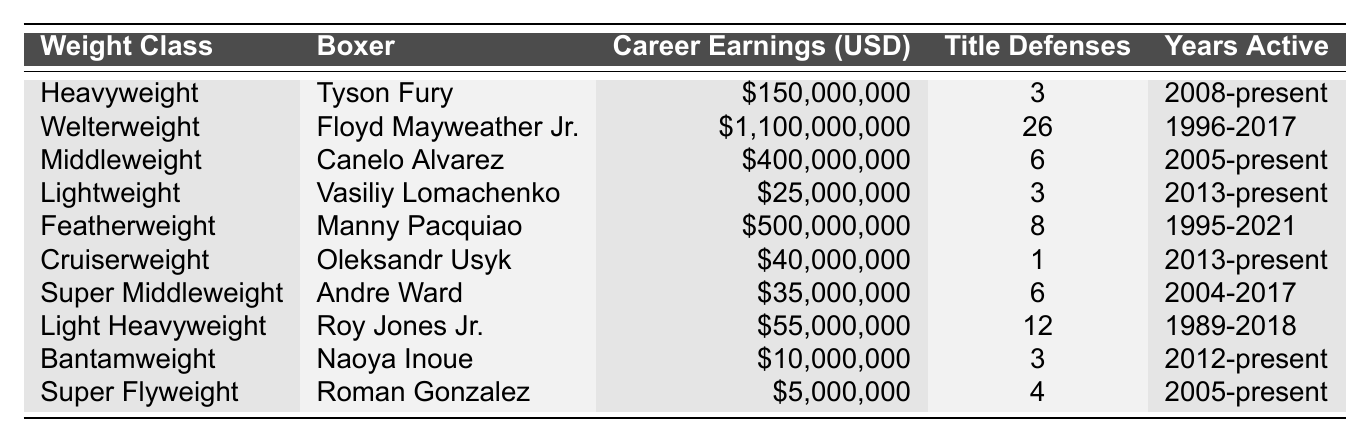What is the career earnings of Floyd Mayweather Jr.? The table lists Floyd Mayweather Jr. under the "Welterweight" weight class with career earnings of \$1,100,000,000.
Answer: \$1,100,000,000 Which boxer has the highest career earnings? By comparing the "Career Earnings (USD)" column, it is clear that Floyd Mayweather Jr. has the highest earnings at \$1,100,000,000.
Answer: Floyd Mayweather Jr How many title defenses does Canelo Alvarez have? The table indicates that Canelo Alvarez, under the "Middleweight" class, has 6 title defenses.
Answer: 6 What is the total number of title defenses for all boxers listed? The title defenses are 3 (Fury) + 26 (Mayweather Jr.) + 6 (Alvarez) + 3 (Lomachenko) + 8 (Pacquiao) + 1 (Usyk) + 6 (Ward) + 12 (Jones Jr.) + 3 (Inoue) + 4 (Gonzalez) = 72.
Answer: 72 What is the average career earnings of the boxers in the cruiserweight and featherweight classes? The career earnings for Oleksandr Usyk (Cruiserweight) is \$40,000,000 and for Manny Pacquiao (Featherweight) is \$500,000,000. Their total earnings are \$40,000,000 + \$500,000,000 = \$540,000,000, and there are 2 boxers, so the average is \$540,000,000 / 2 = \$270,000,000.
Answer: \$270,000,000 Does Naoya Inoue have more career earnings than Roman Gonzalez? The table shows Naoya Inoue with career earnings of \$10,000,000 and Roman Gonzalez with \$5,000,000. Since \$10,000,000 is greater than \$5,000,000, this statement is true.
Answer: Yes Which boxer has the fewest title defenses? Looking at the title defenses, Oleksandr Usyk has only 1 defense, which is the least amount compared to all listed boxers.
Answer: Oleksandr Usyk Is the average career earnings across all boxers more than \$100,000,000? Adding the career earnings gives \$1,100,000,000 + \$150,000,000 + \$400,000,000 + \$25,000,000 + \$500,000,000 + \$40,000,000 + \$35,000,000 + \$55,000,000 + \$10,000,000 + \$5,000,000 = \$2,415,000,000. Divided by 10 boxers results in an average of \$241,500,000, which is more than \$100,000,000.
Answer: Yes Which weight class has the most title defenses in total? Summing the title defenses: Heavyweight 3 + Welterweight 26 + Middleweight 6 + Lightweight 3 + Featherweight 8 + Cruiserweight 1 + Super Middleweight 6 + Light Heavyweight 12 + Bantamweight 3 + Super Flyweight 4 = 72. The Welterweight class contributes the most with 26 defenses.
Answer: Welterweight How many years has Roy Jones Jr. been active? The table indicates that Roy Jones Jr. was active from 1989 to 2018, which is a span of 30 years (2018 - 1989 + 1).
Answer: 30 years 